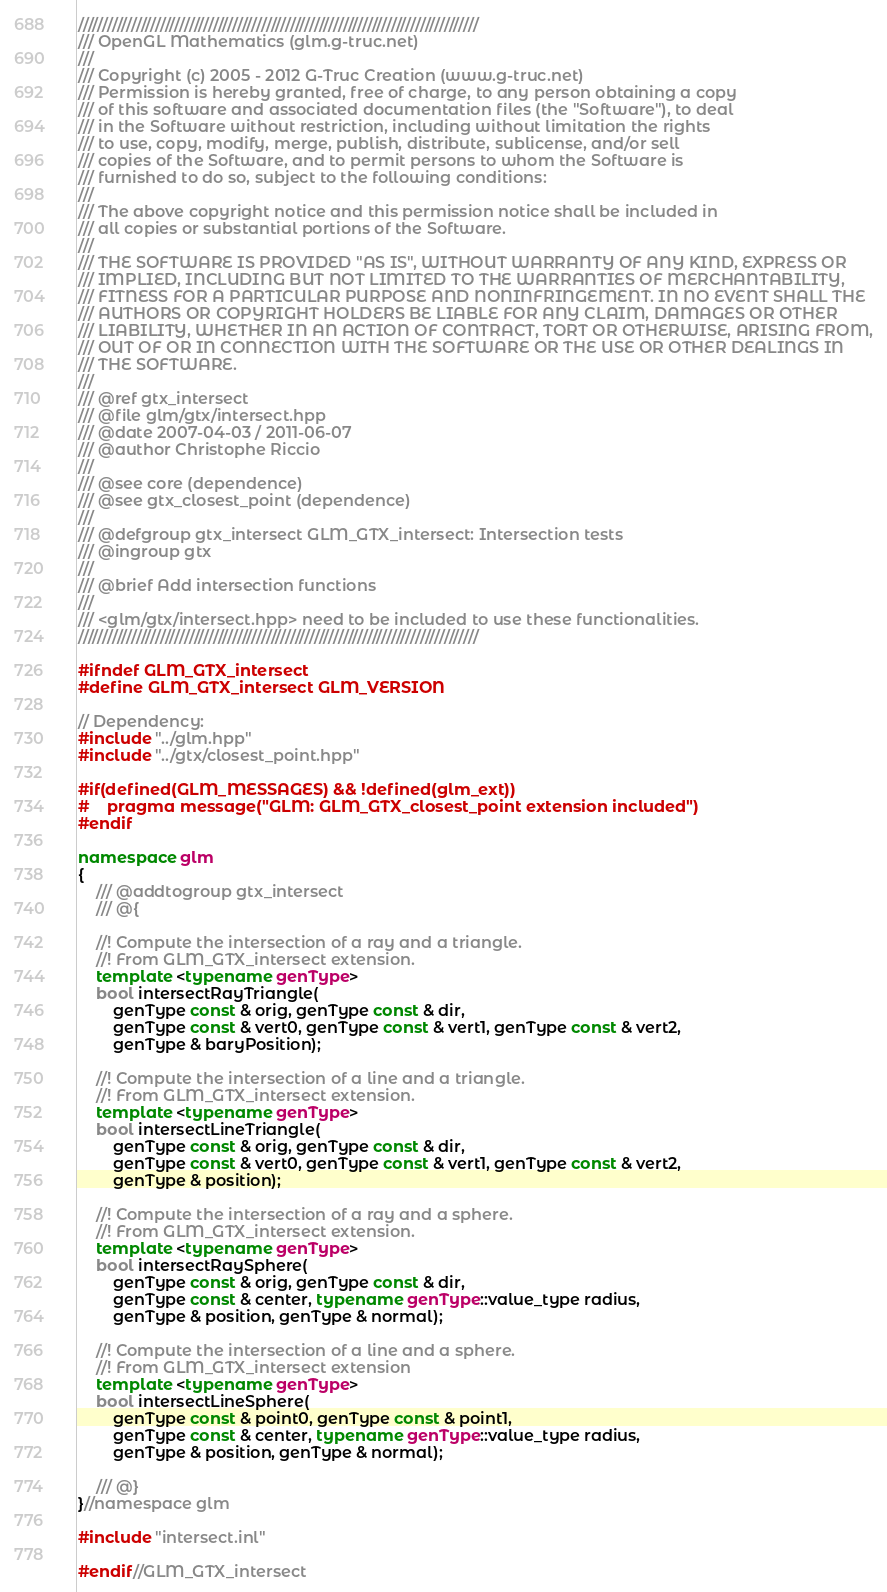<code> <loc_0><loc_0><loc_500><loc_500><_C++_>///////////////////////////////////////////////////////////////////////////////////
/// OpenGL Mathematics (glm.g-truc.net)
///
/// Copyright (c) 2005 - 2012 G-Truc Creation (www.g-truc.net)
/// Permission is hereby granted, free of charge, to any person obtaining a copy
/// of this software and associated documentation files (the "Software"), to deal
/// in the Software without restriction, including without limitation the rights
/// to use, copy, modify, merge, publish, distribute, sublicense, and/or sell
/// copies of the Software, and to permit persons to whom the Software is
/// furnished to do so, subject to the following conditions:
/// 
/// The above copyright notice and this permission notice shall be included in
/// all copies or substantial portions of the Software.
/// 
/// THE SOFTWARE IS PROVIDED "AS IS", WITHOUT WARRANTY OF ANY KIND, EXPRESS OR
/// IMPLIED, INCLUDING BUT NOT LIMITED TO THE WARRANTIES OF MERCHANTABILITY,
/// FITNESS FOR A PARTICULAR PURPOSE AND NONINFRINGEMENT. IN NO EVENT SHALL THE
/// AUTHORS OR COPYRIGHT HOLDERS BE LIABLE FOR ANY CLAIM, DAMAGES OR OTHER
/// LIABILITY, WHETHER IN AN ACTION OF CONTRACT, TORT OR OTHERWISE, ARISING FROM,
/// OUT OF OR IN CONNECTION WITH THE SOFTWARE OR THE USE OR OTHER DEALINGS IN
/// THE SOFTWARE.
///
/// @ref gtx_intersect
/// @file glm/gtx/intersect.hpp
/// @date 2007-04-03 / 2011-06-07
/// @author Christophe Riccio
///
/// @see core (dependence)
/// @see gtx_closest_point (dependence)
///
/// @defgroup gtx_intersect GLM_GTX_intersect: Intersection tests
/// @ingroup gtx
/// 
/// @brief Add intersection functions
/// 
/// <glm/gtx/intersect.hpp> need to be included to use these functionalities.
///////////////////////////////////////////////////////////////////////////////////

#ifndef GLM_GTX_intersect
#define GLM_GTX_intersect GLM_VERSION

// Dependency:
#include "../glm.hpp"
#include "../gtx/closest_point.hpp"

#if(defined(GLM_MESSAGES) && !defined(glm_ext))
#	pragma message("GLM: GLM_GTX_closest_point extension included")
#endif

namespace glm
{
	/// @addtogroup gtx_intersect
	/// @{

	//! Compute the intersection of a ray and a triangle.
	//! From GLM_GTX_intersect extension.
	template <typename genType>
	bool intersectRayTriangle(
		genType const & orig, genType const & dir,
		genType const & vert0, genType const & vert1, genType const & vert2,
		genType & baryPosition);

    //! Compute the intersection of a line and a triangle.
	//! From GLM_GTX_intersect extension.
	template <typename genType>
	bool intersectLineTriangle(
		genType const & orig, genType const & dir,
		genType const & vert0, genType const & vert1, genType const & vert2,
		genType & position);

    //! Compute the intersection of a ray and a sphere.
	//! From GLM_GTX_intersect extension.
	template <typename genType>
	bool intersectRaySphere(
		genType const & orig, genType const & dir,
		genType const & center, typename genType::value_type radius,
		genType & position, genType & normal);

    //! Compute the intersection of a line and a sphere.
	//! From GLM_GTX_intersect extension
	template <typename genType>
	bool intersectLineSphere(
		genType const & point0, genType const & point1,
		genType const & center, typename genType::value_type radius,
		genType & position, genType & normal);

	/// @}
}//namespace glm

#include "intersect.inl"

#endif//GLM_GTX_intersect
</code> 